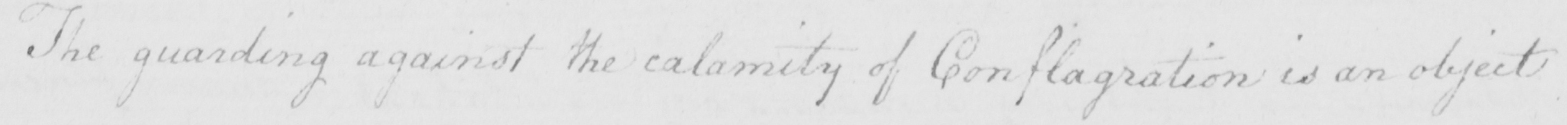Can you tell me what this handwritten text says? The guarding against the calamity of Conflagration is an object 